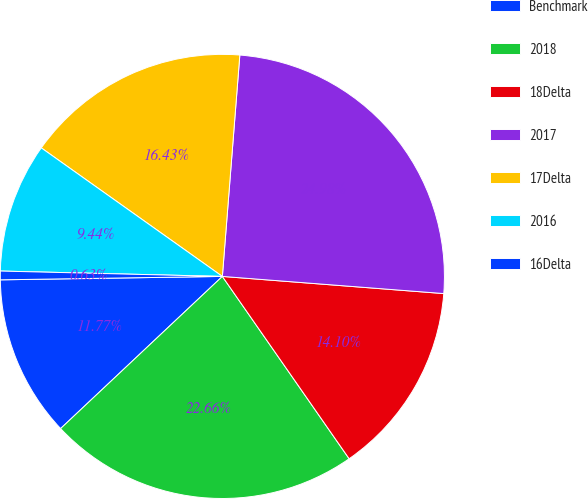<chart> <loc_0><loc_0><loc_500><loc_500><pie_chart><fcel>Benchmark<fcel>2018<fcel>18Delta<fcel>2017<fcel>17Delta<fcel>2016<fcel>16Delta<nl><fcel>11.77%<fcel>22.66%<fcel>14.1%<fcel>24.98%<fcel>16.43%<fcel>9.44%<fcel>0.63%<nl></chart> 